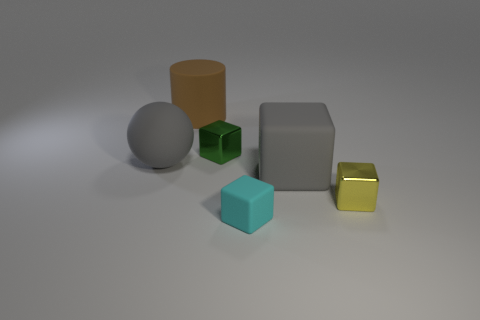Add 2 blue cylinders. How many objects exist? 8 Subtract all cubes. How many objects are left? 2 Add 4 gray matte cubes. How many gray matte cubes exist? 5 Subtract 0 green cylinders. How many objects are left? 6 Subtract all large brown objects. Subtract all large balls. How many objects are left? 4 Add 3 tiny cyan matte blocks. How many tiny cyan matte blocks are left? 4 